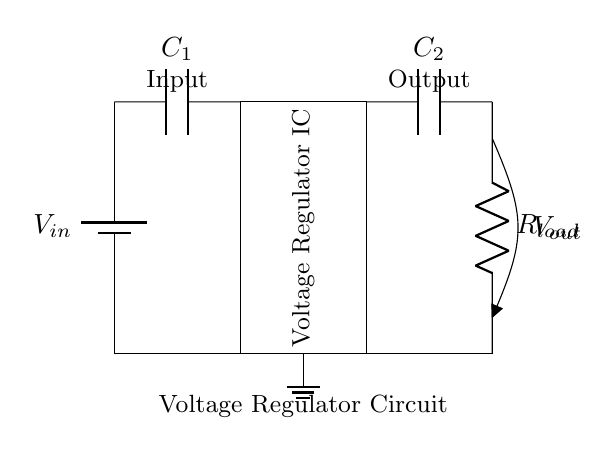What is the voltage source in the circuit? The voltage source is labeled V_in, indicating the input voltage for the circuit.
Answer: V_in What components are connected in series? In the circuit, the capacitor C1 and the voltage regulator IC are connected in series from the voltage source.
Answer: C1, Voltage Regulator IC What is the load connected to the output? The output is connected to a load resistor labeled R_load, which consumes the regulated voltage.
Answer: R_load Why is there a capacitor C2 at the output? Capacitor C2 at the output smooths out the voltage and reduces ripple, ensuring a stable voltage supply to the load.
Answer: To stabilize output voltage What is the role of the voltage regulator IC? The voltage regulator IC stabilizes the output voltage V_out, making sure it remains constant regardless of variations in input voltage or load.
Answer: Stabilizing output voltage What happens if V_in is too low? If V_in is below the minimum required voltage, the voltage regulator cannot maintain the output voltage, potentially leading to insufficient power for the load.
Answer: Insufficient output voltage What frequency of capacitors C1 and C2 is suitable for this circuit? Typically, ceramic or electrolytic capacitors with a frequency rating suitable for the application's decoupling and filtering needs are used in such circuits.
Answer: Low frequency 